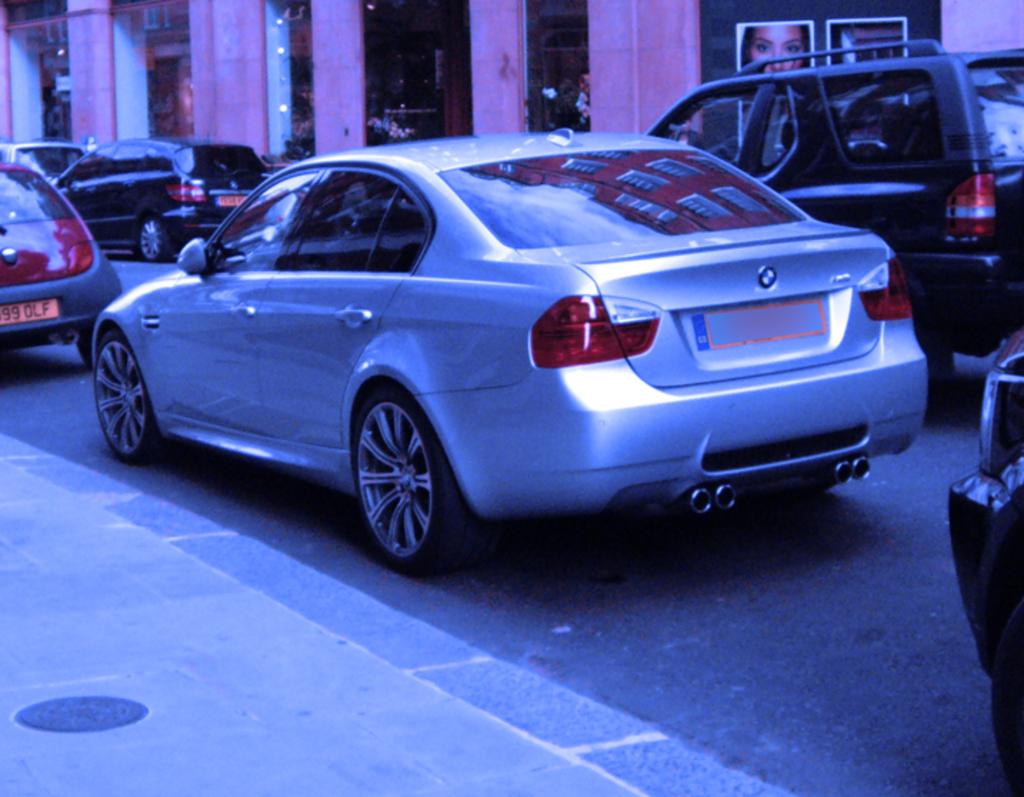What type of vehicles can be seen on the road in the image? There are cars on the road in the image. What structures can be seen in the background? There are pillars, lights, and posters in the background. Are there any people visible in the image? Yes, there are persons in the background. Where is the bed located in the image? There is no bed present in the image. Can you describe the coastline visible in the image? There is no coastline visible in the image. 